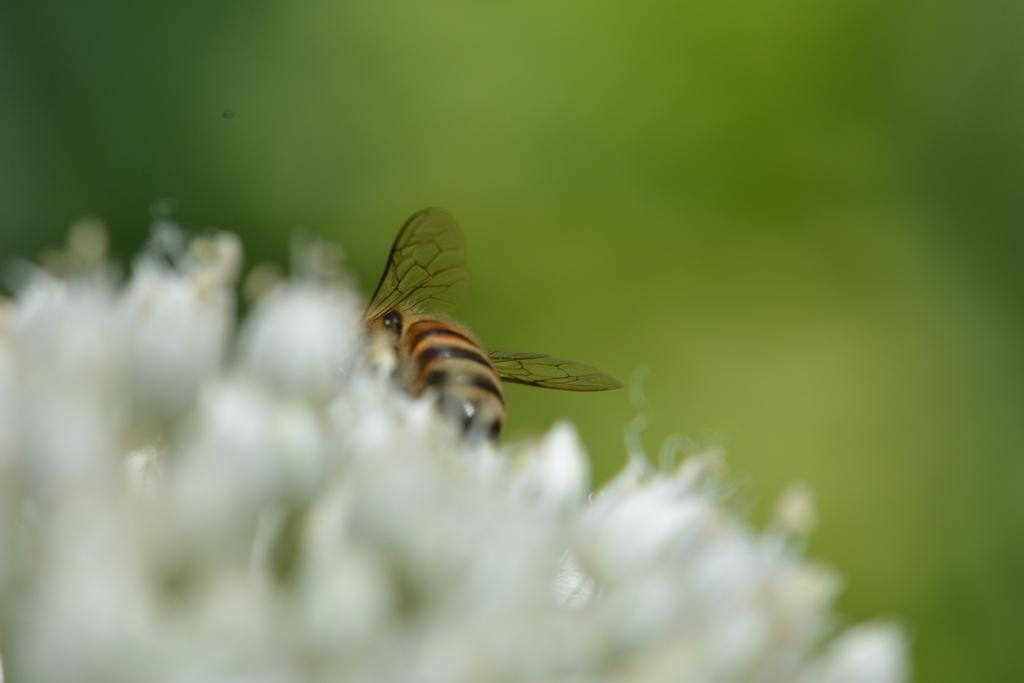What type of creature can be seen in the image? There is an insect in the image. Where is the insect located in the image? The insect is on a flower. What type of bubble can be seen in the image? There is no bubble present in the image. 